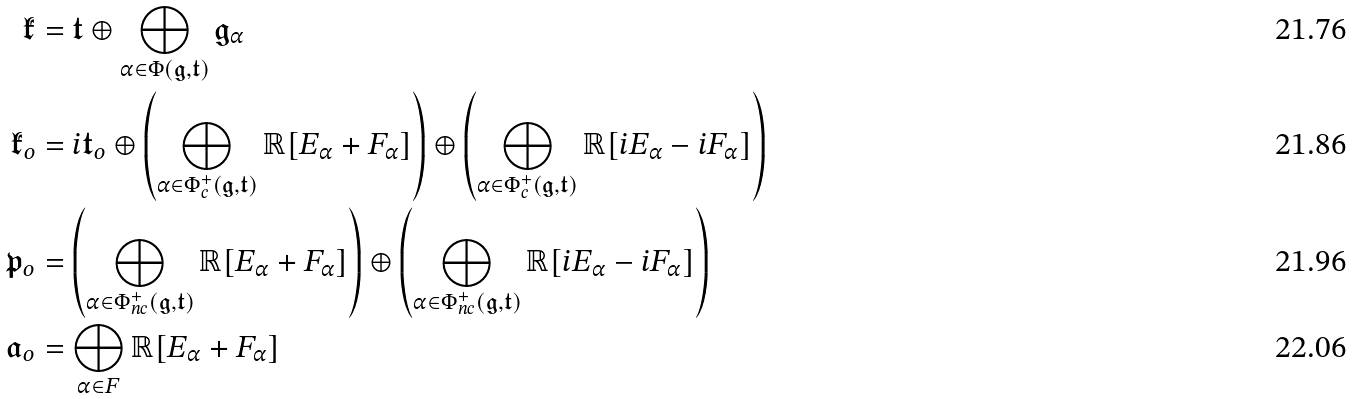<formula> <loc_0><loc_0><loc_500><loc_500>\mathfrak { k } & = \mathfrak { t } \oplus \bigoplus _ { \alpha \in \Phi ( \mathfrak { g } , \mathfrak { t } ) } \mathfrak { g } _ { \alpha } \\ \mathfrak { k } _ { o } & = i \mathfrak { t } _ { o } \oplus \left ( \bigoplus _ { \alpha \in \Phi _ { c } ^ { + } ( \mathfrak { g } , \mathfrak { t } ) } \mathbb { R } [ E _ { \alpha } + F _ { \alpha } ] \right ) \oplus \left ( \bigoplus _ { \alpha \in \Phi _ { c } ^ { + } ( \mathfrak { g } , \mathfrak { t } ) } \mathbb { R } [ i E _ { \alpha } - i F _ { \alpha } ] \right ) \\ \mathfrak { p } _ { o } & = \left ( \bigoplus _ { \alpha \in \Phi ^ { + } _ { n c } ( \mathfrak { g } , \mathfrak { t } ) } \mathbb { R } [ E _ { \alpha } + F _ { \alpha } ] \right ) \oplus \left ( \bigoplus _ { \alpha \in \Phi _ { n c } ^ { + } ( \mathfrak { g } , \mathfrak { t } ) } \mathbb { R } [ i E _ { \alpha } - i F _ { \alpha } ] \right ) \\ \mathfrak { a } _ { o } & = \bigoplus _ { \alpha \in F } \mathbb { R } [ E _ { \alpha } + F _ { \alpha } ]</formula> 